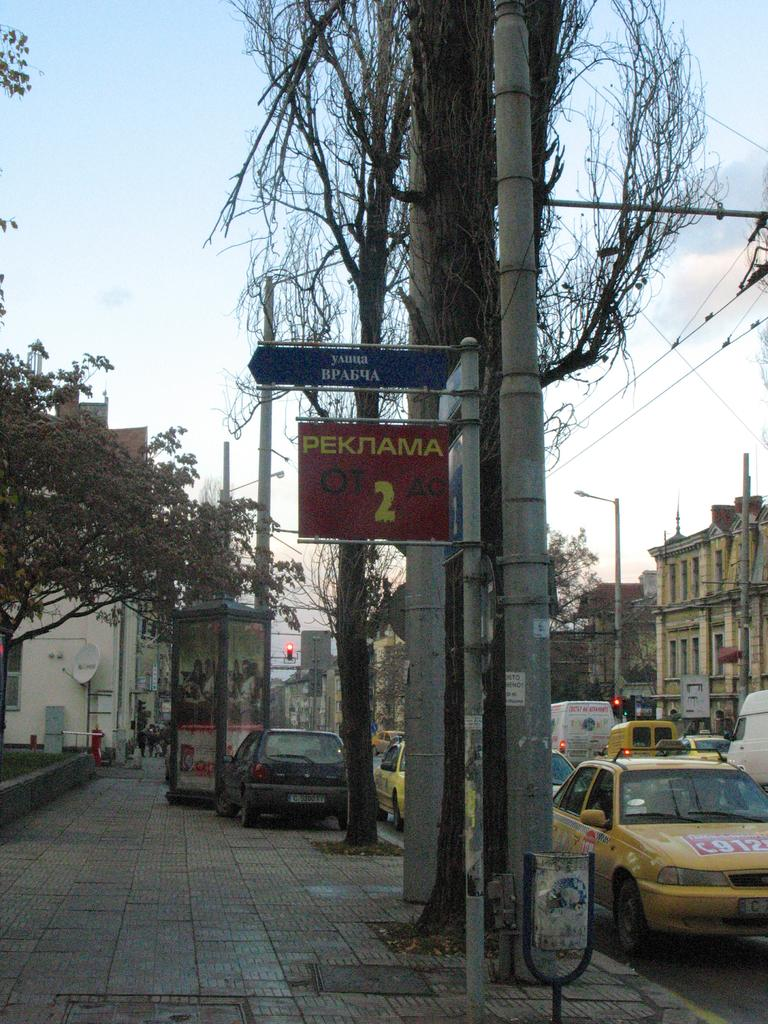<image>
Describe the image concisely. Street sign next to a taxi cab that says Peknama 2. 